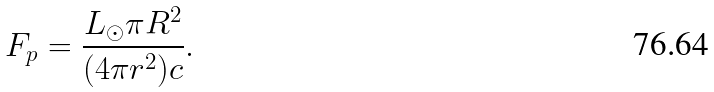Convert formula to latex. <formula><loc_0><loc_0><loc_500><loc_500>F _ { p } = \frac { L _ { \odot } \pi R ^ { 2 } } { ( 4 \pi r ^ { 2 } ) c } .</formula> 